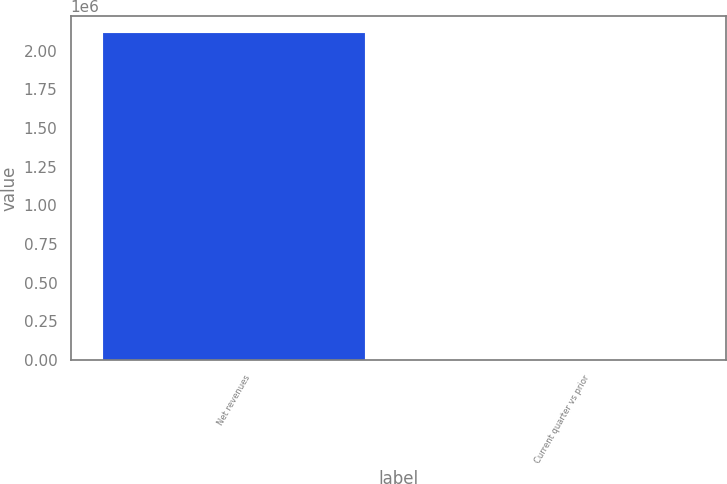<chart> <loc_0><loc_0><loc_500><loc_500><bar_chart><fcel>Net revenues<fcel>Current quarter vs prior<nl><fcel>2.11753e+06<fcel>7<nl></chart> 